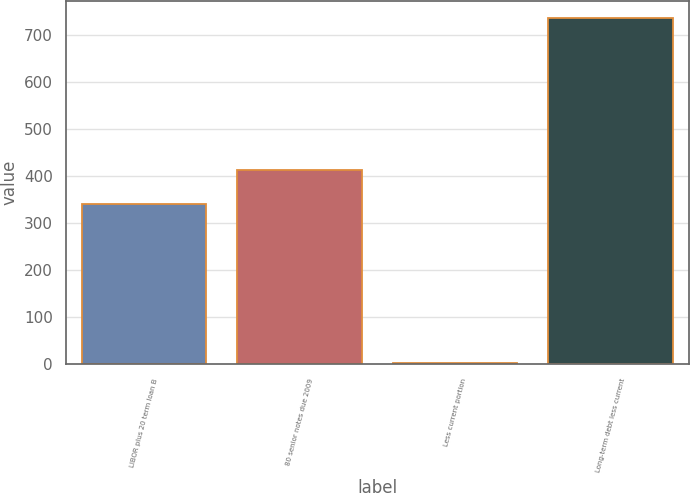Convert chart to OTSL. <chart><loc_0><loc_0><loc_500><loc_500><bar_chart><fcel>LIBOR plus 20 term loan B<fcel>80 senior notes due 2009<fcel>Less current portion<fcel>Long-term debt less current<nl><fcel>340<fcel>413.2<fcel>4<fcel>736<nl></chart> 